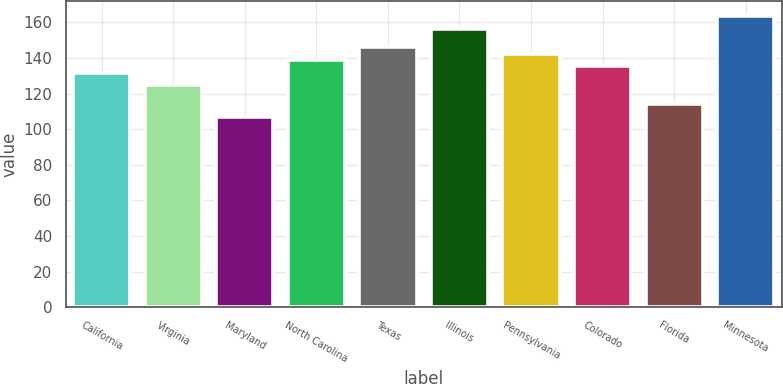Convert chart. <chart><loc_0><loc_0><loc_500><loc_500><bar_chart><fcel>California<fcel>Virginia<fcel>Maryland<fcel>North Carolina<fcel>Texas<fcel>Illinois<fcel>Pennsylvania<fcel>Colorado<fcel>Florida<fcel>Minnesota<nl><fcel>131.78<fcel>124.7<fcel>107<fcel>138.86<fcel>145.94<fcel>156.56<fcel>142.4<fcel>135.32<fcel>114.08<fcel>163.64<nl></chart> 